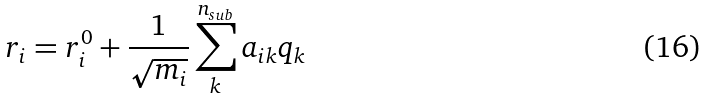Convert formula to latex. <formula><loc_0><loc_0><loc_500><loc_500>r _ { i } = r _ { i } ^ { 0 } + \frac { 1 } { \sqrt { m _ { i } } } \sum _ { k } ^ { n _ { s u b } } a _ { i k } q _ { k }</formula> 